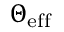<formula> <loc_0><loc_0><loc_500><loc_500>\Theta _ { e f f }</formula> 